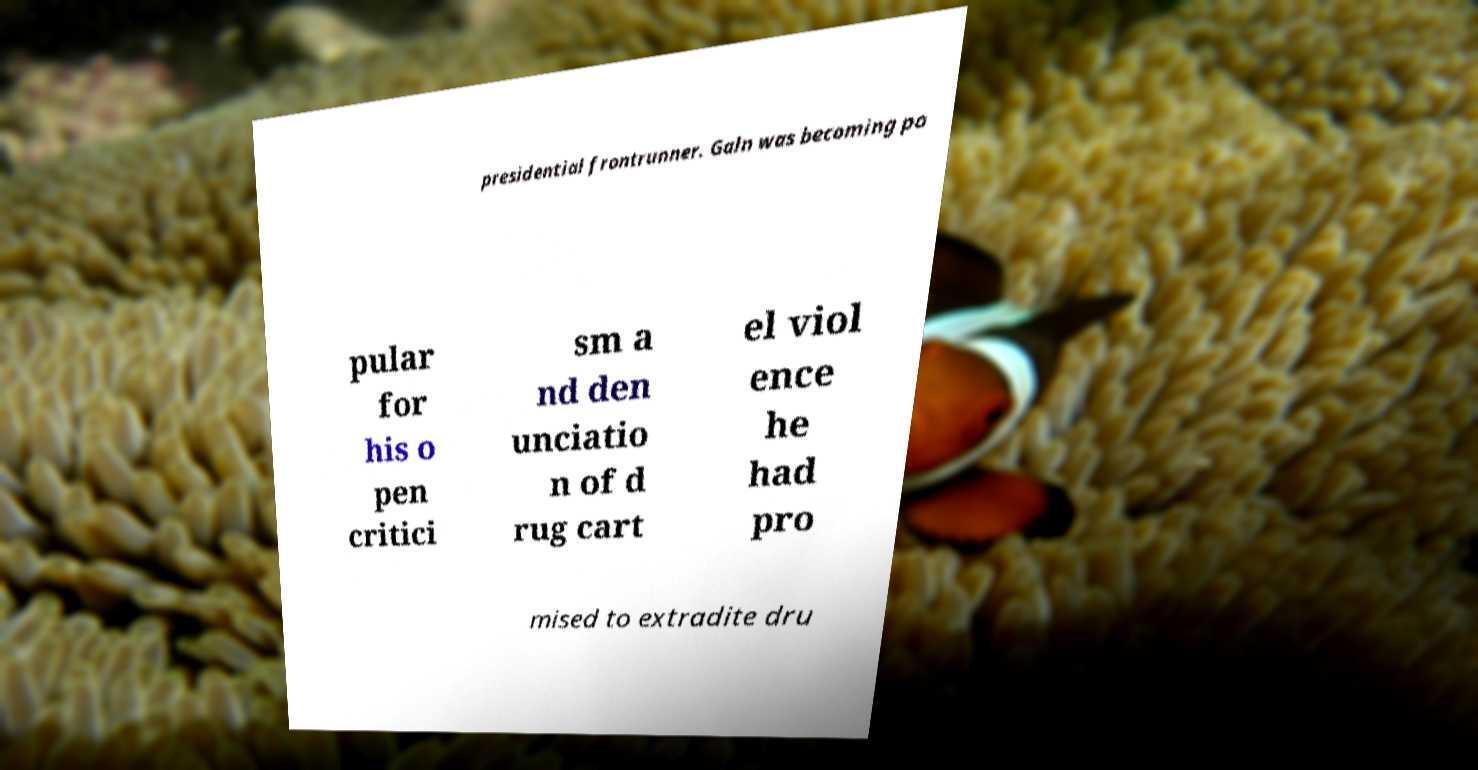I need the written content from this picture converted into text. Can you do that? presidential frontrunner. Galn was becoming po pular for his o pen critici sm a nd den unciatio n of d rug cart el viol ence he had pro mised to extradite dru 